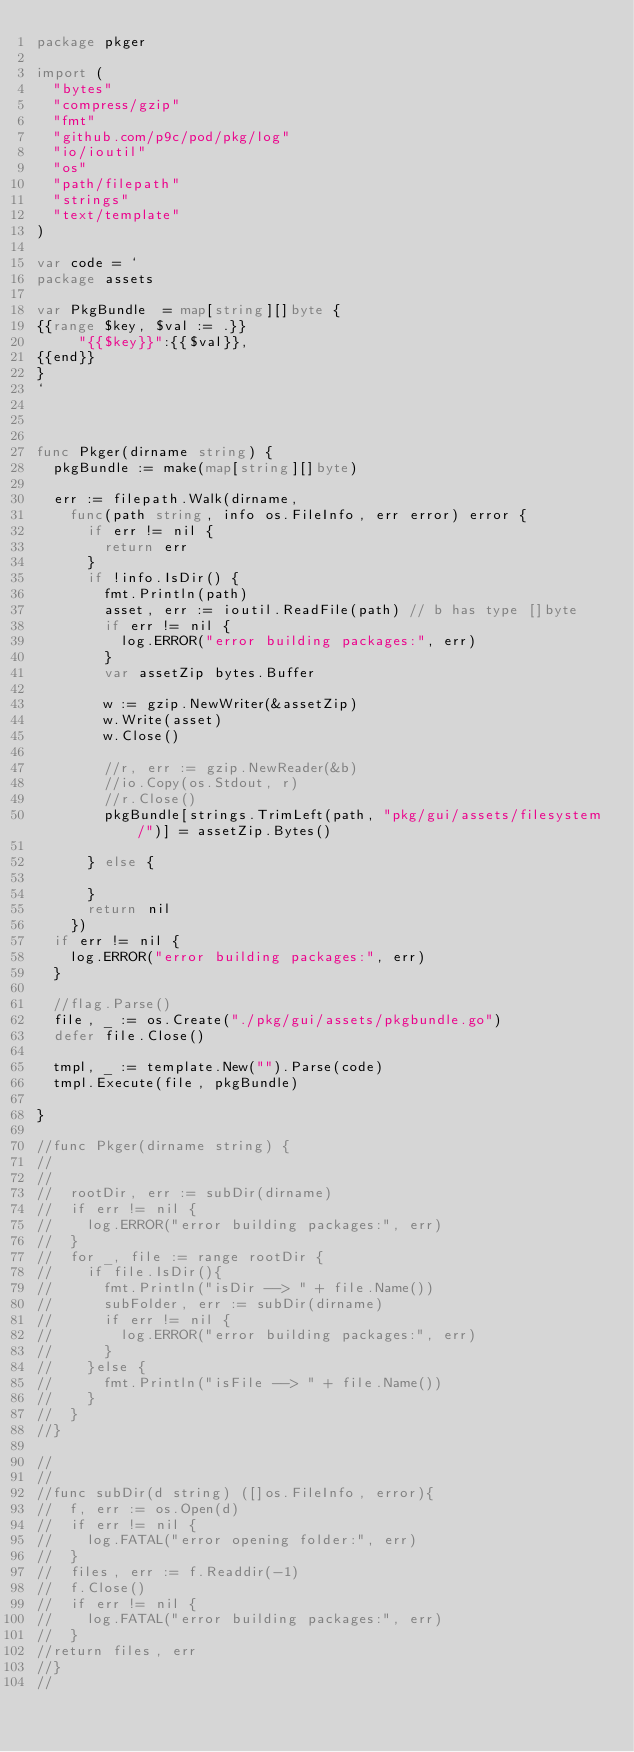<code> <loc_0><loc_0><loc_500><loc_500><_Go_>package pkger

import (
	"bytes"
	"compress/gzip"
	"fmt"
	"github.com/p9c/pod/pkg/log"
	"io/ioutil"
	"os"
	"path/filepath"
	"strings"
	"text/template"
)

var code = `
package assets

var PkgBundle  = map[string][]byte {
{{range $key, $val := .}}
     "{{$key}}":{{$val}},
{{end}}
}
`



func Pkger(dirname string) {
	pkgBundle := make(map[string][]byte)

	err := filepath.Walk(dirname,
		func(path string, info os.FileInfo, err error) error {
			if err != nil {
				return err
			}
			if !info.IsDir() {
				fmt.Println(path)
				asset, err := ioutil.ReadFile(path) // b has type []byte
				if err != nil {
					log.ERROR("error building packages:", err)
				}
				var assetZip bytes.Buffer

				w := gzip.NewWriter(&assetZip)
				w.Write(asset)
				w.Close()

				//r, err := gzip.NewReader(&b)
				//io.Copy(os.Stdout, r)
				//r.Close()
				pkgBundle[strings.TrimLeft(path, "pkg/gui/assets/filesystem/")] = assetZip.Bytes()

			} else {

			}
			return nil
		})
	if err != nil {
		log.ERROR("error building packages:", err)
	}

	//flag.Parse()
	file, _ := os.Create("./pkg/gui/assets/pkgbundle.go")
	defer file.Close()

	tmpl, _ := template.New("").Parse(code)
	tmpl.Execute(file, pkgBundle)

}

//func Pkger(dirname string) {
//
//
//	rootDir, err := subDir(dirname)
//	if err != nil {
//		log.ERROR("error building packages:", err)
//	}
//	for _, file := range rootDir {
//		if file.IsDir(){
//			fmt.Println("isDir --> " + file.Name())
//			subFolder, err := subDir(dirname)
//			if err != nil {
//				log.ERROR("error building packages:", err)
//			}
//		}else {
//			fmt.Println("isFile --> " + file.Name())
//		}
//	}
//}

//
//
//func subDir(d string) ([]os.FileInfo, error){
//	f, err := os.Open(d)
//	if err != nil {
//		log.FATAL("error opening folder:", err)
//	}
//	files, err := f.Readdir(-1)
//	f.Close()
//	if err != nil {
//		log.FATAL("error building packages:", err)
//	}
//return files, err
//}
//
</code> 